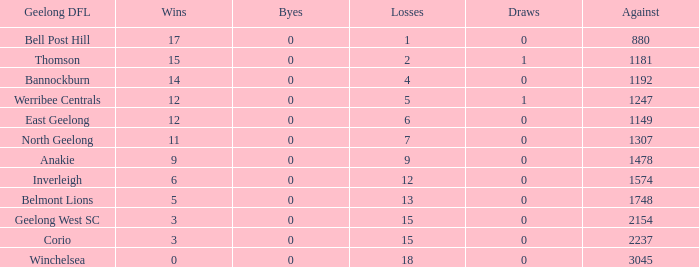What are the average losses for Geelong DFL of Bell Post Hill where the draws are less than 0? None. 